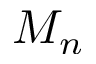Convert formula to latex. <formula><loc_0><loc_0><loc_500><loc_500>M _ { n }</formula> 